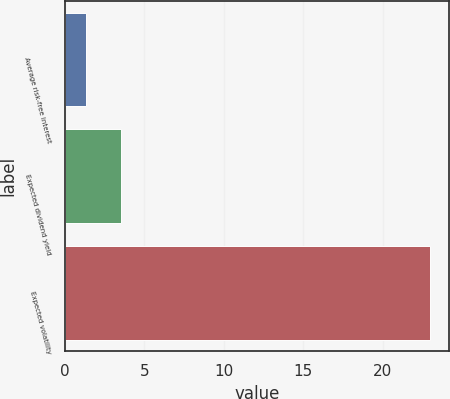Convert chart to OTSL. <chart><loc_0><loc_0><loc_500><loc_500><bar_chart><fcel>Average risk-free interest<fcel>Expected dividend yield<fcel>Expected volatility<nl><fcel>1.35<fcel>3.52<fcel>23<nl></chart> 